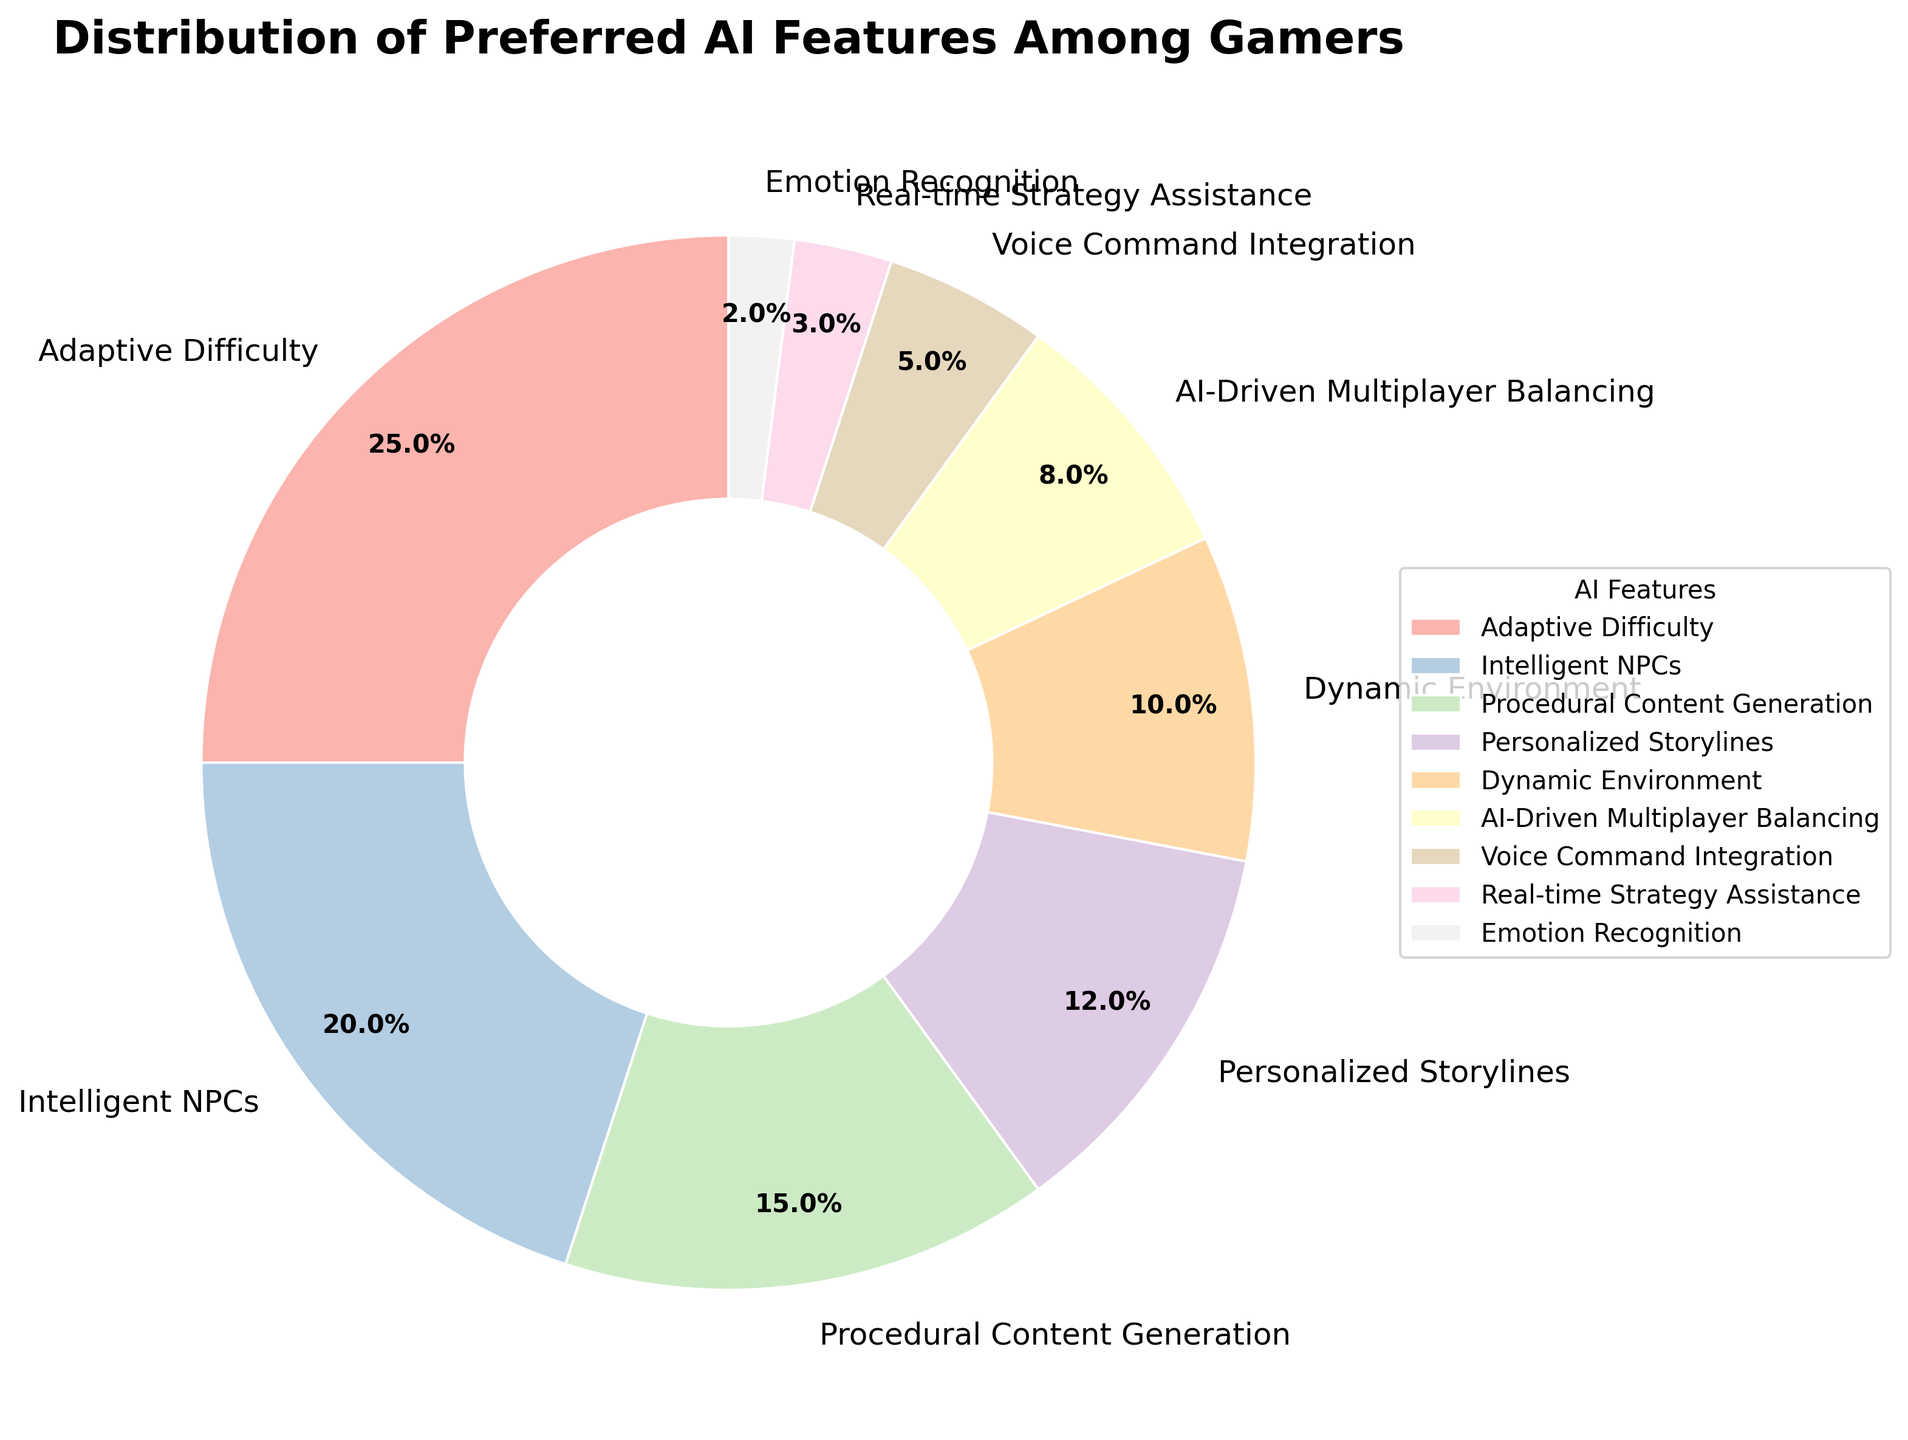What AI feature do gamers prefer the most? To determine which AI feature gamers prefer the most, look at the pie slice with the largest percentage. The largest slice represents 'Adaptive Difficulty' with 25%.
Answer: Adaptive Difficulty Which AI feature is preferred less: Intelligent NPCs or Dynamic Environment? Compare the percentages associated with 'Intelligent NPCs' and 'Dynamic Environment'. 'Intelligent NPCs' has 20%, while 'Dynamic Environment' has 10%.
Answer: Dynamic Environment What is the total percentage for AI-Driven Multiplayer Balancing and Voice Command Integration combined? Add the percentages for these two features. AI-Driven Multiplayer Balancing is 8% and Voice Command Integration is 5%. So, 8% + 5% = 13%.
Answer: 13% Which AI feature occupies roughly one-fourth of the pie chart? Look for the feature that covers approximately 25% of the pie chart. The 'Adaptive Difficulty' slice is exactly 25%.
Answer: Adaptive Difficulty What's the difference in percentage between Procedural Content Generation and Real-time Strategy Assistance? Subtract the percentage of Real-time Strategy Assistance from Procedural Content Generation. Procedural Content Generation is 15%, and Real-time Strategy Assistance is 3%. So, 15% - 3% = 12%.
Answer: 12% Are there any AI features that occupy less than 5% of the pie chart? If yes, name them. Identify slices that represent less than 5% each. Real-time Strategy Assistance is 3%, and Emotion Recognition is 2%.
Answer: Real-time Strategy Assistance and Emotion Recognition What is the combined percentage of Personalized Storylines, Dynamic Environment, and Emotion Recognition? Sum the percentages of these three features. Personalized Storylines is 12%, Dynamic Environment is 10%, and Emotion Recognition is 2%. So, 12% + 10% + 2% = 24%.
Answer: 24% Which AI feature is preferred more: Personalized Storylines or Procedural Content Generation? Compare the percentages for 'Personalized Storylines' and 'Procedural Content Generation'. Personalized Storylines is 12%, and Procedural Content Generation is 15%.
Answer: Procedural Content Generation How much more preferred is Adaptive Difficulty compared to Emotion Recognition? Subtract the percentage of Emotion Recognition from Adaptive Difficulty. Adaptive Difficulty is 25%, and Emotion Recognition is 2%. So, 25% - 2% = 23%.
Answer: 23% What would be the new percentage of Intelligent NPCs if its representation doubled? Multiply the percentage of Intelligent NPCs by 2. Intelligent NPCs are currently 20%. Doubling it would be 20% * 2 = 40%.
Answer: 40% 